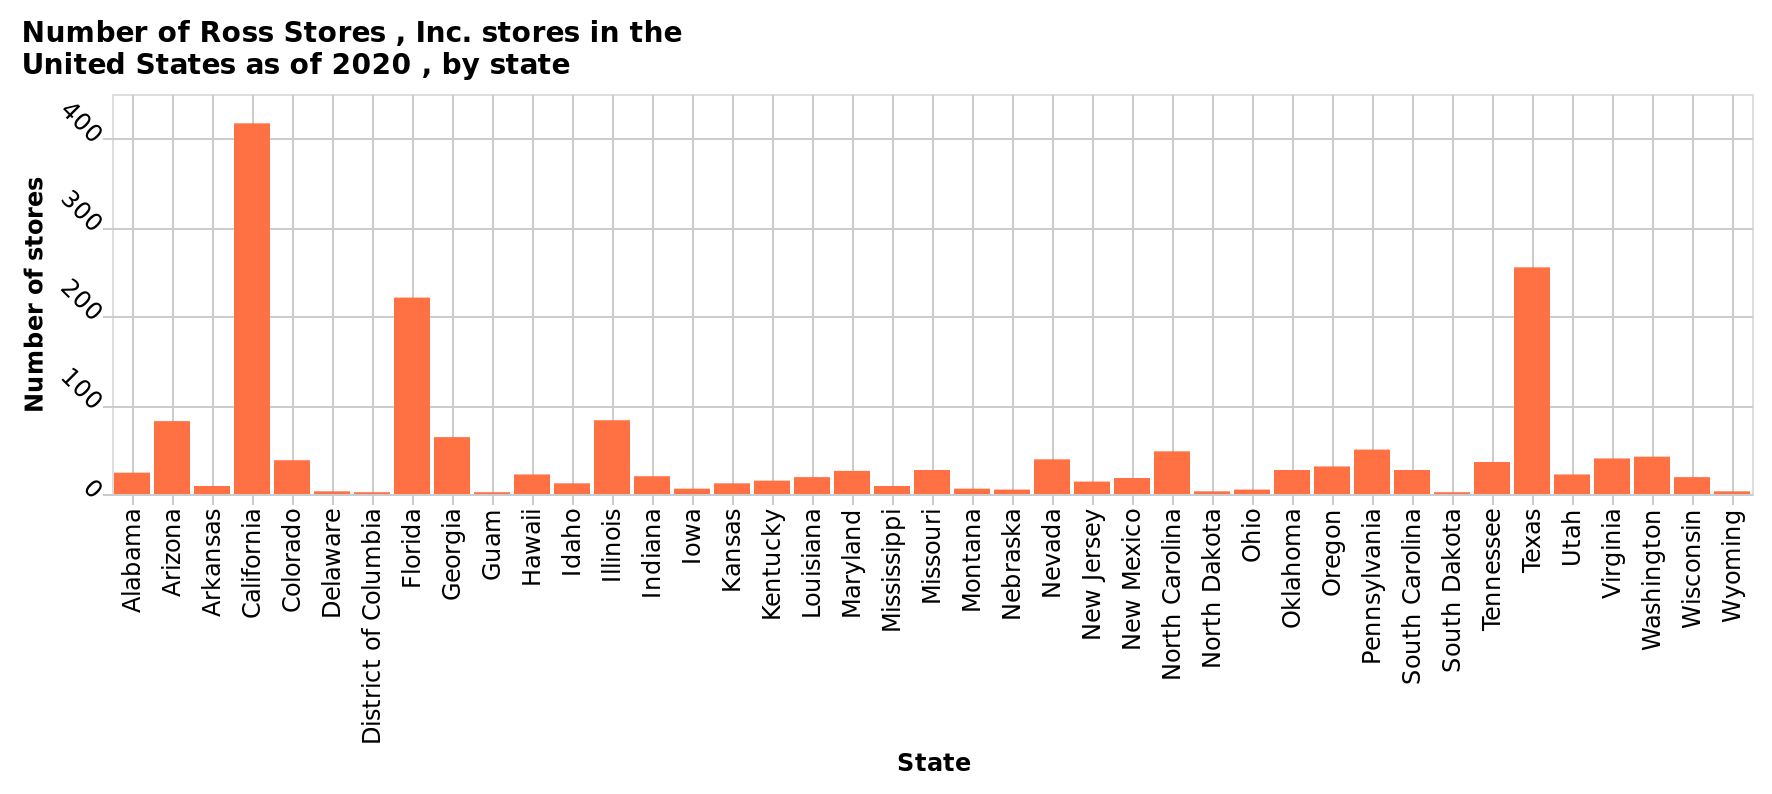<image>
What is the range of number of Ross Stores shown on the y-axis? The range of number of Ross Stores shown on the y-axis is from 0 to 400. 